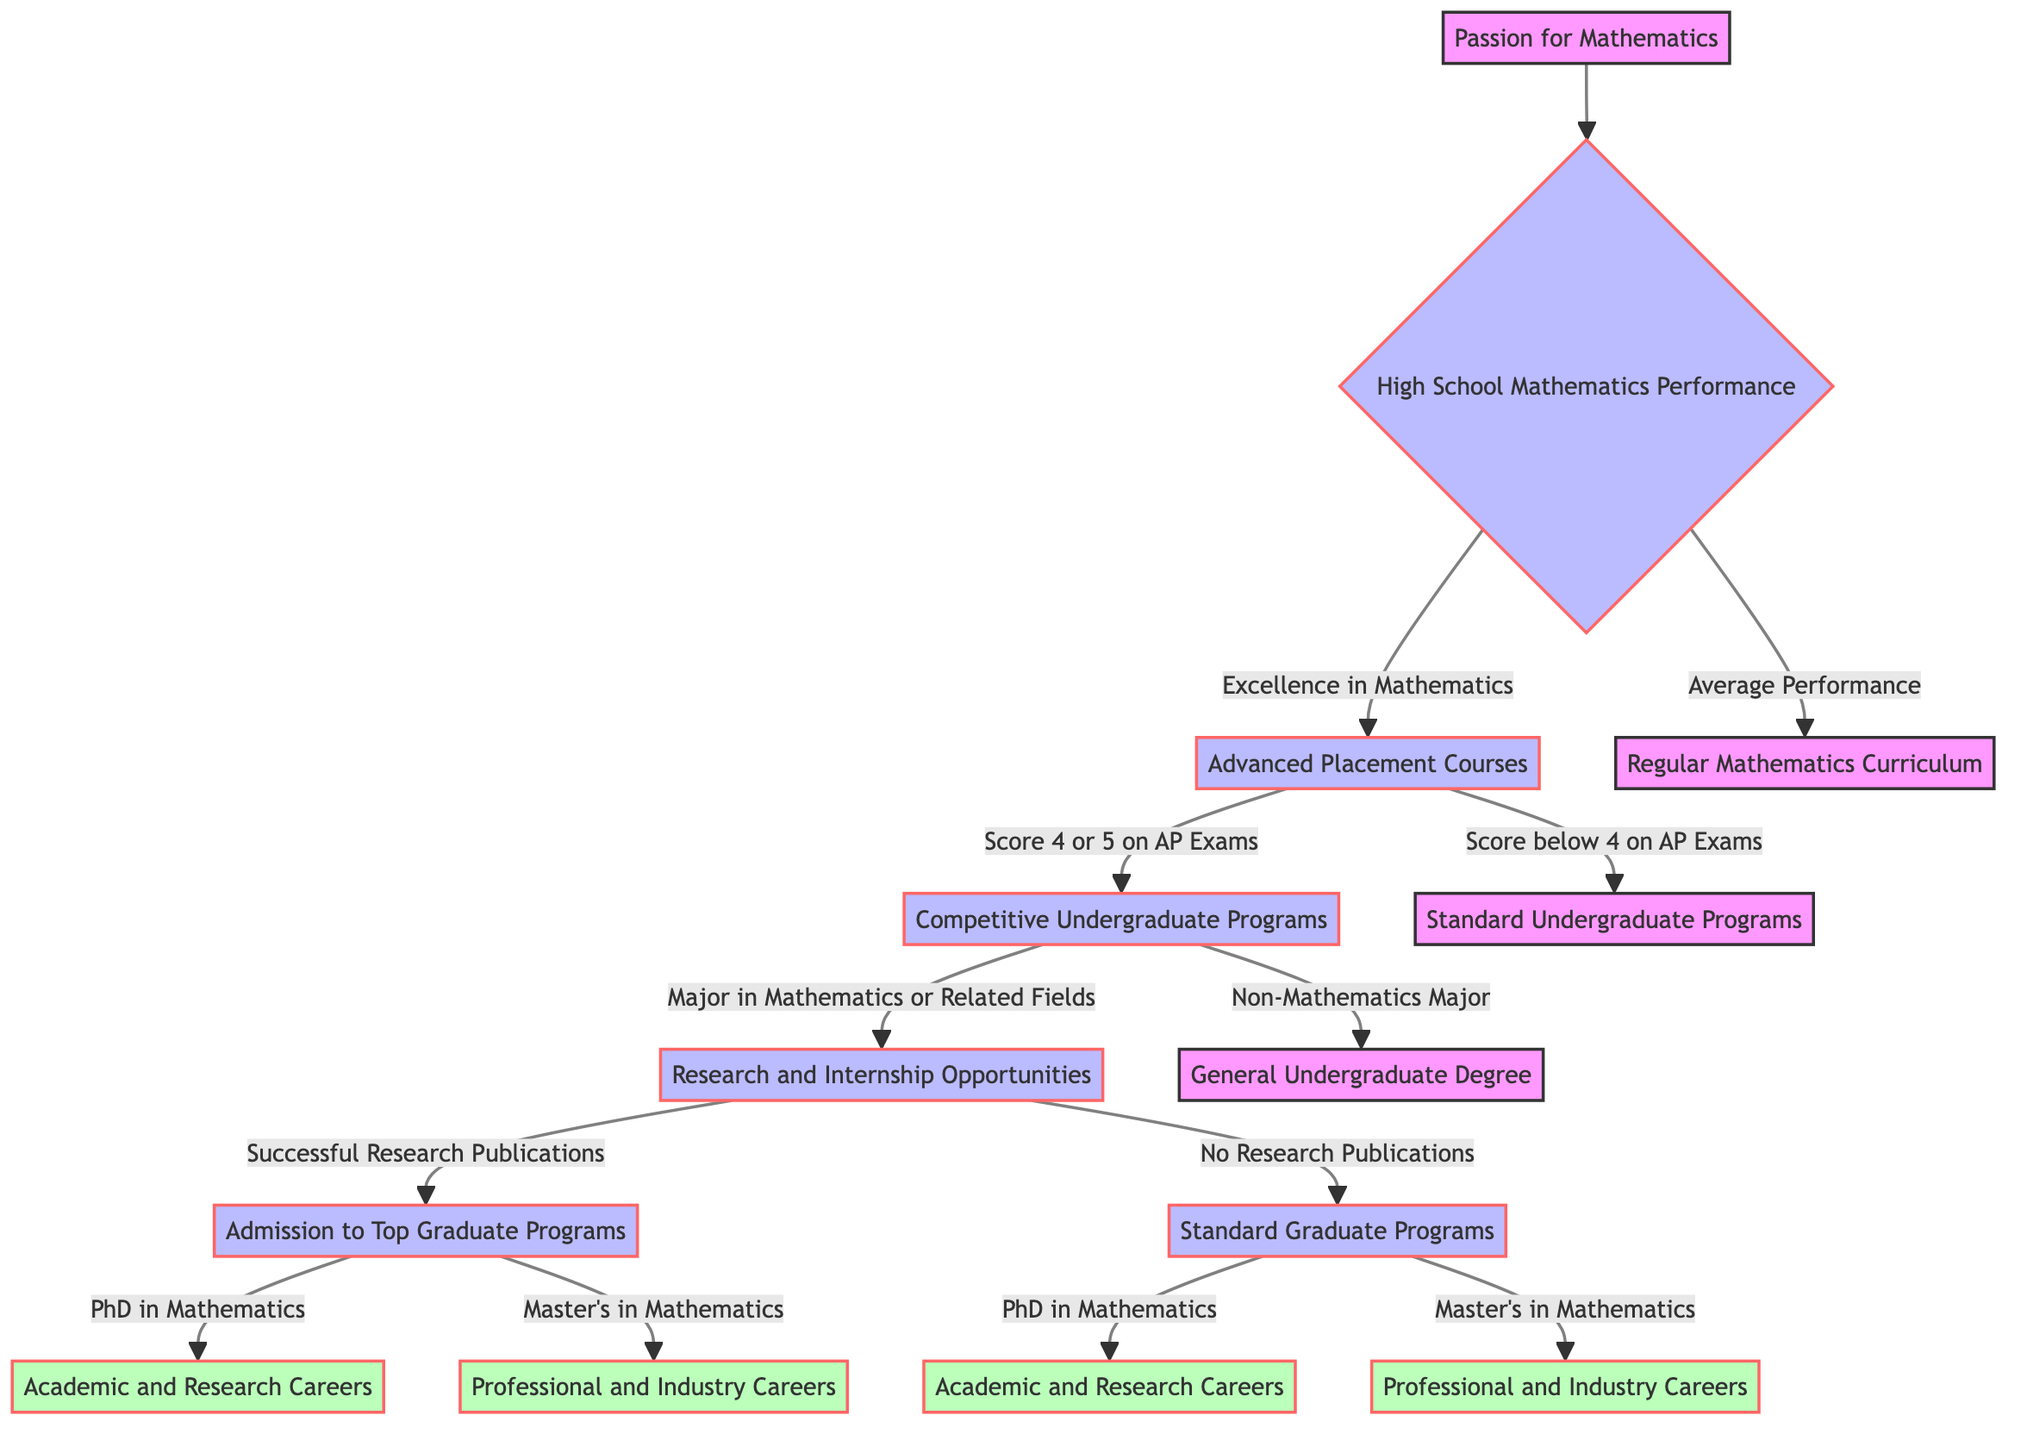What is the starting point of the decision tree? The starting point is the initial node labeled "Passion for Mathematics", which represents the motivation for pursuing advanced mathematics degrees.
Answer: Passion for Mathematics How many choices are there after "High School Mathematics Performance"? There are two choices described under the "High School Mathematics Performance" node: "Excellence in Mathematics" and "Average Performance".
Answer: 2 What is the outcome if a student scores 4 or 5 on AP Exams? Scoring 4 or 5 on AP Exams leads to the outcome of "Competitive Undergraduate Programs".
Answer: Competitive Undergraduate Programs If a student has "No Research Publications", what is the next step in their path? If a student has "No Research Publications", they move to the "Standard Graduate Programs" after "Research and Internship Opportunities".
Answer: Standard Graduate Programs What happens if a student majors in a non-mathematics field during their undergraduate study? If a student majors in a non-mathematics field, they will end up with a "General Undergraduate Degree" after "Competitive Undergraduate Programs".
Answer: General Undergraduate Degree What are the two possible outcomes after attending "Top Graduate Programs"? The two outcomes after attending "Top Graduate Programs" are "Academic and Research Careers" for a PhD and "Professional and Industry Careers" for a Master's degree.
Answer: Academic and Research Careers, Professional and Industry Careers What are the conditions for a student to be admitted to Top Graduate Programs? A student is admitted to Top Graduate Programs if they have "Successful Research Publications" after attending "Research and Internship Opportunities".
Answer: Successful Research Publications What is the final possible path for someone in Standard Graduate Programs with a PhD? For someone in Standard Graduate Programs who pursues a PhD in Mathematics, the final path is "Academic and Research Careers".
Answer: Academic and Research Careers What is the total number of distinct nodes in the decision tree? The total number of distinct nodes in the decision tree, including the starting point and outcomes, is ten: "Passion for Mathematics," "High School Mathematics Performance," "Advanced Placement Courses," "Regular Mathematics Curriculum," "Competitive Undergraduate Programs," "Standard Undergraduate Programs," "Research and Internship Opportunities," "General Undergraduate Degree," "Top Graduate Programs," and "Standard Graduate Programs".
Answer: 10 